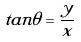<formula> <loc_0><loc_0><loc_500><loc_500>t a n \theta = \frac { y } { x }</formula> 